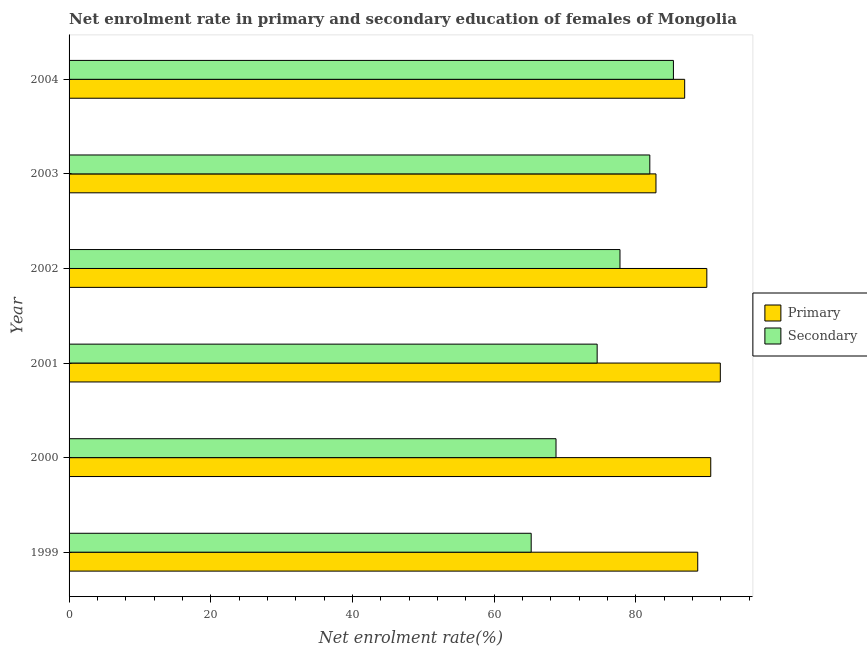Are the number of bars per tick equal to the number of legend labels?
Provide a succinct answer. Yes. Are the number of bars on each tick of the Y-axis equal?
Make the answer very short. Yes. What is the label of the 2nd group of bars from the top?
Your answer should be compact. 2003. In how many cases, is the number of bars for a given year not equal to the number of legend labels?
Make the answer very short. 0. What is the enrollment rate in primary education in 1999?
Your answer should be very brief. 88.72. Across all years, what is the maximum enrollment rate in primary education?
Ensure brevity in your answer.  91.9. Across all years, what is the minimum enrollment rate in secondary education?
Provide a short and direct response. 65.22. In which year was the enrollment rate in secondary education maximum?
Offer a terse response. 2004. What is the total enrollment rate in primary education in the graph?
Offer a terse response. 530.88. What is the difference between the enrollment rate in primary education in 2000 and that in 2003?
Your response must be concise. 7.73. What is the difference between the enrollment rate in primary education in 2004 and the enrollment rate in secondary education in 2003?
Your response must be concise. 4.92. What is the average enrollment rate in primary education per year?
Provide a short and direct response. 88.48. In the year 2003, what is the difference between the enrollment rate in primary education and enrollment rate in secondary education?
Keep it short and to the point. 0.87. What is the ratio of the enrollment rate in primary education in 2001 to that in 2003?
Provide a succinct answer. 1.11. Is the enrollment rate in primary education in 1999 less than that in 2000?
Provide a short and direct response. Yes. What is the difference between the highest and the second highest enrollment rate in primary education?
Your answer should be very brief. 1.35. What is the difference between the highest and the lowest enrollment rate in secondary education?
Provide a short and direct response. 20.07. What does the 1st bar from the top in 2004 represents?
Your response must be concise. Secondary. What does the 1st bar from the bottom in 2003 represents?
Ensure brevity in your answer.  Primary. How many bars are there?
Ensure brevity in your answer.  12. Are all the bars in the graph horizontal?
Give a very brief answer. Yes. Are the values on the major ticks of X-axis written in scientific E-notation?
Your response must be concise. No. Does the graph contain any zero values?
Ensure brevity in your answer.  No. Does the graph contain grids?
Provide a succinct answer. No. How many legend labels are there?
Your answer should be very brief. 2. How are the legend labels stacked?
Provide a short and direct response. Vertical. What is the title of the graph?
Keep it short and to the point. Net enrolment rate in primary and secondary education of females of Mongolia. Does "Services" appear as one of the legend labels in the graph?
Keep it short and to the point. No. What is the label or title of the X-axis?
Offer a very short reply. Net enrolment rate(%). What is the Net enrolment rate(%) of Primary in 1999?
Your response must be concise. 88.72. What is the Net enrolment rate(%) of Secondary in 1999?
Provide a short and direct response. 65.22. What is the Net enrolment rate(%) of Primary in 2000?
Make the answer very short. 90.56. What is the Net enrolment rate(%) of Secondary in 2000?
Make the answer very short. 68.72. What is the Net enrolment rate(%) of Primary in 2001?
Your answer should be very brief. 91.9. What is the Net enrolment rate(%) of Secondary in 2001?
Your answer should be very brief. 74.53. What is the Net enrolment rate(%) in Primary in 2002?
Provide a short and direct response. 90. What is the Net enrolment rate(%) in Secondary in 2002?
Make the answer very short. 77.75. What is the Net enrolment rate(%) in Primary in 2003?
Your response must be concise. 82.83. What is the Net enrolment rate(%) in Secondary in 2003?
Your answer should be compact. 81.96. What is the Net enrolment rate(%) in Primary in 2004?
Give a very brief answer. 86.87. What is the Net enrolment rate(%) in Secondary in 2004?
Keep it short and to the point. 85.29. Across all years, what is the maximum Net enrolment rate(%) of Primary?
Offer a very short reply. 91.9. Across all years, what is the maximum Net enrolment rate(%) of Secondary?
Your response must be concise. 85.29. Across all years, what is the minimum Net enrolment rate(%) in Primary?
Your answer should be compact. 82.83. Across all years, what is the minimum Net enrolment rate(%) of Secondary?
Ensure brevity in your answer.  65.22. What is the total Net enrolment rate(%) in Primary in the graph?
Your answer should be very brief. 530.88. What is the total Net enrolment rate(%) in Secondary in the graph?
Provide a succinct answer. 453.45. What is the difference between the Net enrolment rate(%) of Primary in 1999 and that in 2000?
Provide a succinct answer. -1.84. What is the difference between the Net enrolment rate(%) in Secondary in 1999 and that in 2000?
Offer a terse response. -3.5. What is the difference between the Net enrolment rate(%) in Primary in 1999 and that in 2001?
Provide a succinct answer. -3.19. What is the difference between the Net enrolment rate(%) in Secondary in 1999 and that in 2001?
Offer a very short reply. -9.31. What is the difference between the Net enrolment rate(%) of Primary in 1999 and that in 2002?
Offer a terse response. -1.28. What is the difference between the Net enrolment rate(%) in Secondary in 1999 and that in 2002?
Your answer should be compact. -12.53. What is the difference between the Net enrolment rate(%) of Primary in 1999 and that in 2003?
Offer a very short reply. 5.89. What is the difference between the Net enrolment rate(%) in Secondary in 1999 and that in 2003?
Provide a succinct answer. -16.74. What is the difference between the Net enrolment rate(%) of Primary in 1999 and that in 2004?
Give a very brief answer. 1.84. What is the difference between the Net enrolment rate(%) of Secondary in 1999 and that in 2004?
Ensure brevity in your answer.  -20.07. What is the difference between the Net enrolment rate(%) of Primary in 2000 and that in 2001?
Your response must be concise. -1.35. What is the difference between the Net enrolment rate(%) in Secondary in 2000 and that in 2001?
Ensure brevity in your answer.  -5.81. What is the difference between the Net enrolment rate(%) of Primary in 2000 and that in 2002?
Provide a succinct answer. 0.55. What is the difference between the Net enrolment rate(%) of Secondary in 2000 and that in 2002?
Offer a terse response. -9.03. What is the difference between the Net enrolment rate(%) of Primary in 2000 and that in 2003?
Give a very brief answer. 7.73. What is the difference between the Net enrolment rate(%) of Secondary in 2000 and that in 2003?
Keep it short and to the point. -13.24. What is the difference between the Net enrolment rate(%) in Primary in 2000 and that in 2004?
Your answer should be very brief. 3.68. What is the difference between the Net enrolment rate(%) of Secondary in 2000 and that in 2004?
Provide a short and direct response. -16.57. What is the difference between the Net enrolment rate(%) of Primary in 2001 and that in 2002?
Offer a very short reply. 1.9. What is the difference between the Net enrolment rate(%) of Secondary in 2001 and that in 2002?
Your answer should be compact. -3.22. What is the difference between the Net enrolment rate(%) of Primary in 2001 and that in 2003?
Provide a short and direct response. 9.08. What is the difference between the Net enrolment rate(%) of Secondary in 2001 and that in 2003?
Provide a succinct answer. -7.43. What is the difference between the Net enrolment rate(%) of Primary in 2001 and that in 2004?
Your answer should be compact. 5.03. What is the difference between the Net enrolment rate(%) of Secondary in 2001 and that in 2004?
Make the answer very short. -10.76. What is the difference between the Net enrolment rate(%) in Primary in 2002 and that in 2003?
Offer a terse response. 7.18. What is the difference between the Net enrolment rate(%) in Secondary in 2002 and that in 2003?
Keep it short and to the point. -4.21. What is the difference between the Net enrolment rate(%) of Primary in 2002 and that in 2004?
Provide a succinct answer. 3.13. What is the difference between the Net enrolment rate(%) in Secondary in 2002 and that in 2004?
Your answer should be compact. -7.54. What is the difference between the Net enrolment rate(%) in Primary in 2003 and that in 2004?
Your answer should be very brief. -4.05. What is the difference between the Net enrolment rate(%) in Secondary in 2003 and that in 2004?
Make the answer very short. -3.33. What is the difference between the Net enrolment rate(%) in Primary in 1999 and the Net enrolment rate(%) in Secondary in 2000?
Ensure brevity in your answer.  20. What is the difference between the Net enrolment rate(%) in Primary in 1999 and the Net enrolment rate(%) in Secondary in 2001?
Provide a succinct answer. 14.19. What is the difference between the Net enrolment rate(%) in Primary in 1999 and the Net enrolment rate(%) in Secondary in 2002?
Your answer should be compact. 10.97. What is the difference between the Net enrolment rate(%) of Primary in 1999 and the Net enrolment rate(%) of Secondary in 2003?
Your response must be concise. 6.76. What is the difference between the Net enrolment rate(%) in Primary in 1999 and the Net enrolment rate(%) in Secondary in 2004?
Make the answer very short. 3.43. What is the difference between the Net enrolment rate(%) of Primary in 2000 and the Net enrolment rate(%) of Secondary in 2001?
Keep it short and to the point. 16.03. What is the difference between the Net enrolment rate(%) in Primary in 2000 and the Net enrolment rate(%) in Secondary in 2002?
Provide a short and direct response. 12.81. What is the difference between the Net enrolment rate(%) in Primary in 2000 and the Net enrolment rate(%) in Secondary in 2003?
Your answer should be very brief. 8.6. What is the difference between the Net enrolment rate(%) of Primary in 2000 and the Net enrolment rate(%) of Secondary in 2004?
Provide a succinct answer. 5.27. What is the difference between the Net enrolment rate(%) in Primary in 2001 and the Net enrolment rate(%) in Secondary in 2002?
Your answer should be very brief. 14.16. What is the difference between the Net enrolment rate(%) of Primary in 2001 and the Net enrolment rate(%) of Secondary in 2003?
Ensure brevity in your answer.  9.95. What is the difference between the Net enrolment rate(%) in Primary in 2001 and the Net enrolment rate(%) in Secondary in 2004?
Provide a succinct answer. 6.62. What is the difference between the Net enrolment rate(%) of Primary in 2002 and the Net enrolment rate(%) of Secondary in 2003?
Your answer should be compact. 8.05. What is the difference between the Net enrolment rate(%) of Primary in 2002 and the Net enrolment rate(%) of Secondary in 2004?
Your answer should be compact. 4.72. What is the difference between the Net enrolment rate(%) in Primary in 2003 and the Net enrolment rate(%) in Secondary in 2004?
Ensure brevity in your answer.  -2.46. What is the average Net enrolment rate(%) in Primary per year?
Give a very brief answer. 88.48. What is the average Net enrolment rate(%) in Secondary per year?
Your response must be concise. 75.58. In the year 1999, what is the difference between the Net enrolment rate(%) in Primary and Net enrolment rate(%) in Secondary?
Make the answer very short. 23.5. In the year 2000, what is the difference between the Net enrolment rate(%) in Primary and Net enrolment rate(%) in Secondary?
Ensure brevity in your answer.  21.84. In the year 2001, what is the difference between the Net enrolment rate(%) of Primary and Net enrolment rate(%) of Secondary?
Make the answer very short. 17.38. In the year 2002, what is the difference between the Net enrolment rate(%) of Primary and Net enrolment rate(%) of Secondary?
Offer a terse response. 12.26. In the year 2003, what is the difference between the Net enrolment rate(%) of Primary and Net enrolment rate(%) of Secondary?
Offer a terse response. 0.87. In the year 2004, what is the difference between the Net enrolment rate(%) in Primary and Net enrolment rate(%) in Secondary?
Provide a succinct answer. 1.59. What is the ratio of the Net enrolment rate(%) in Primary in 1999 to that in 2000?
Make the answer very short. 0.98. What is the ratio of the Net enrolment rate(%) of Secondary in 1999 to that in 2000?
Make the answer very short. 0.95. What is the ratio of the Net enrolment rate(%) in Primary in 1999 to that in 2001?
Make the answer very short. 0.97. What is the ratio of the Net enrolment rate(%) of Secondary in 1999 to that in 2001?
Make the answer very short. 0.88. What is the ratio of the Net enrolment rate(%) of Primary in 1999 to that in 2002?
Provide a succinct answer. 0.99. What is the ratio of the Net enrolment rate(%) of Secondary in 1999 to that in 2002?
Make the answer very short. 0.84. What is the ratio of the Net enrolment rate(%) of Primary in 1999 to that in 2003?
Keep it short and to the point. 1.07. What is the ratio of the Net enrolment rate(%) in Secondary in 1999 to that in 2003?
Your answer should be very brief. 0.8. What is the ratio of the Net enrolment rate(%) of Primary in 1999 to that in 2004?
Your answer should be compact. 1.02. What is the ratio of the Net enrolment rate(%) of Secondary in 1999 to that in 2004?
Ensure brevity in your answer.  0.76. What is the ratio of the Net enrolment rate(%) in Secondary in 2000 to that in 2001?
Ensure brevity in your answer.  0.92. What is the ratio of the Net enrolment rate(%) of Primary in 2000 to that in 2002?
Give a very brief answer. 1.01. What is the ratio of the Net enrolment rate(%) of Secondary in 2000 to that in 2002?
Your answer should be very brief. 0.88. What is the ratio of the Net enrolment rate(%) of Primary in 2000 to that in 2003?
Offer a terse response. 1.09. What is the ratio of the Net enrolment rate(%) of Secondary in 2000 to that in 2003?
Provide a short and direct response. 0.84. What is the ratio of the Net enrolment rate(%) of Primary in 2000 to that in 2004?
Your answer should be very brief. 1.04. What is the ratio of the Net enrolment rate(%) in Secondary in 2000 to that in 2004?
Give a very brief answer. 0.81. What is the ratio of the Net enrolment rate(%) in Primary in 2001 to that in 2002?
Offer a very short reply. 1.02. What is the ratio of the Net enrolment rate(%) in Secondary in 2001 to that in 2002?
Offer a terse response. 0.96. What is the ratio of the Net enrolment rate(%) in Primary in 2001 to that in 2003?
Your answer should be compact. 1.11. What is the ratio of the Net enrolment rate(%) in Secondary in 2001 to that in 2003?
Your answer should be compact. 0.91. What is the ratio of the Net enrolment rate(%) in Primary in 2001 to that in 2004?
Your response must be concise. 1.06. What is the ratio of the Net enrolment rate(%) of Secondary in 2001 to that in 2004?
Ensure brevity in your answer.  0.87. What is the ratio of the Net enrolment rate(%) of Primary in 2002 to that in 2003?
Offer a very short reply. 1.09. What is the ratio of the Net enrolment rate(%) of Secondary in 2002 to that in 2003?
Make the answer very short. 0.95. What is the ratio of the Net enrolment rate(%) in Primary in 2002 to that in 2004?
Provide a short and direct response. 1.04. What is the ratio of the Net enrolment rate(%) of Secondary in 2002 to that in 2004?
Offer a terse response. 0.91. What is the ratio of the Net enrolment rate(%) in Primary in 2003 to that in 2004?
Offer a very short reply. 0.95. What is the ratio of the Net enrolment rate(%) in Secondary in 2003 to that in 2004?
Provide a succinct answer. 0.96. What is the difference between the highest and the second highest Net enrolment rate(%) of Primary?
Your response must be concise. 1.35. What is the difference between the highest and the second highest Net enrolment rate(%) of Secondary?
Provide a succinct answer. 3.33. What is the difference between the highest and the lowest Net enrolment rate(%) in Primary?
Your answer should be compact. 9.08. What is the difference between the highest and the lowest Net enrolment rate(%) in Secondary?
Provide a succinct answer. 20.07. 